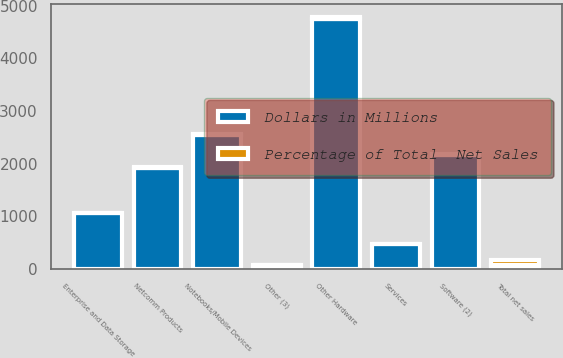<chart> <loc_0><loc_0><loc_500><loc_500><stacked_bar_chart><ecel><fcel>Notebooks/Mobile Devices<fcel>Netcomm Products<fcel>Enterprise and Data Storage<fcel>Other Hardware<fcel>Software (2)<fcel>Services<fcel>Other (3)<fcel>Total net sales<nl><fcel>Dollars in Millions<fcel>2539.4<fcel>1914.9<fcel>1065.2<fcel>4756.4<fcel>2163.6<fcel>478<fcel>71.2<fcel>71.2<nl><fcel>Percentage of Total  Net Sales<fcel>19.6<fcel>14.7<fcel>8.2<fcel>36.6<fcel>16.7<fcel>3.7<fcel>0.5<fcel>100<nl></chart> 